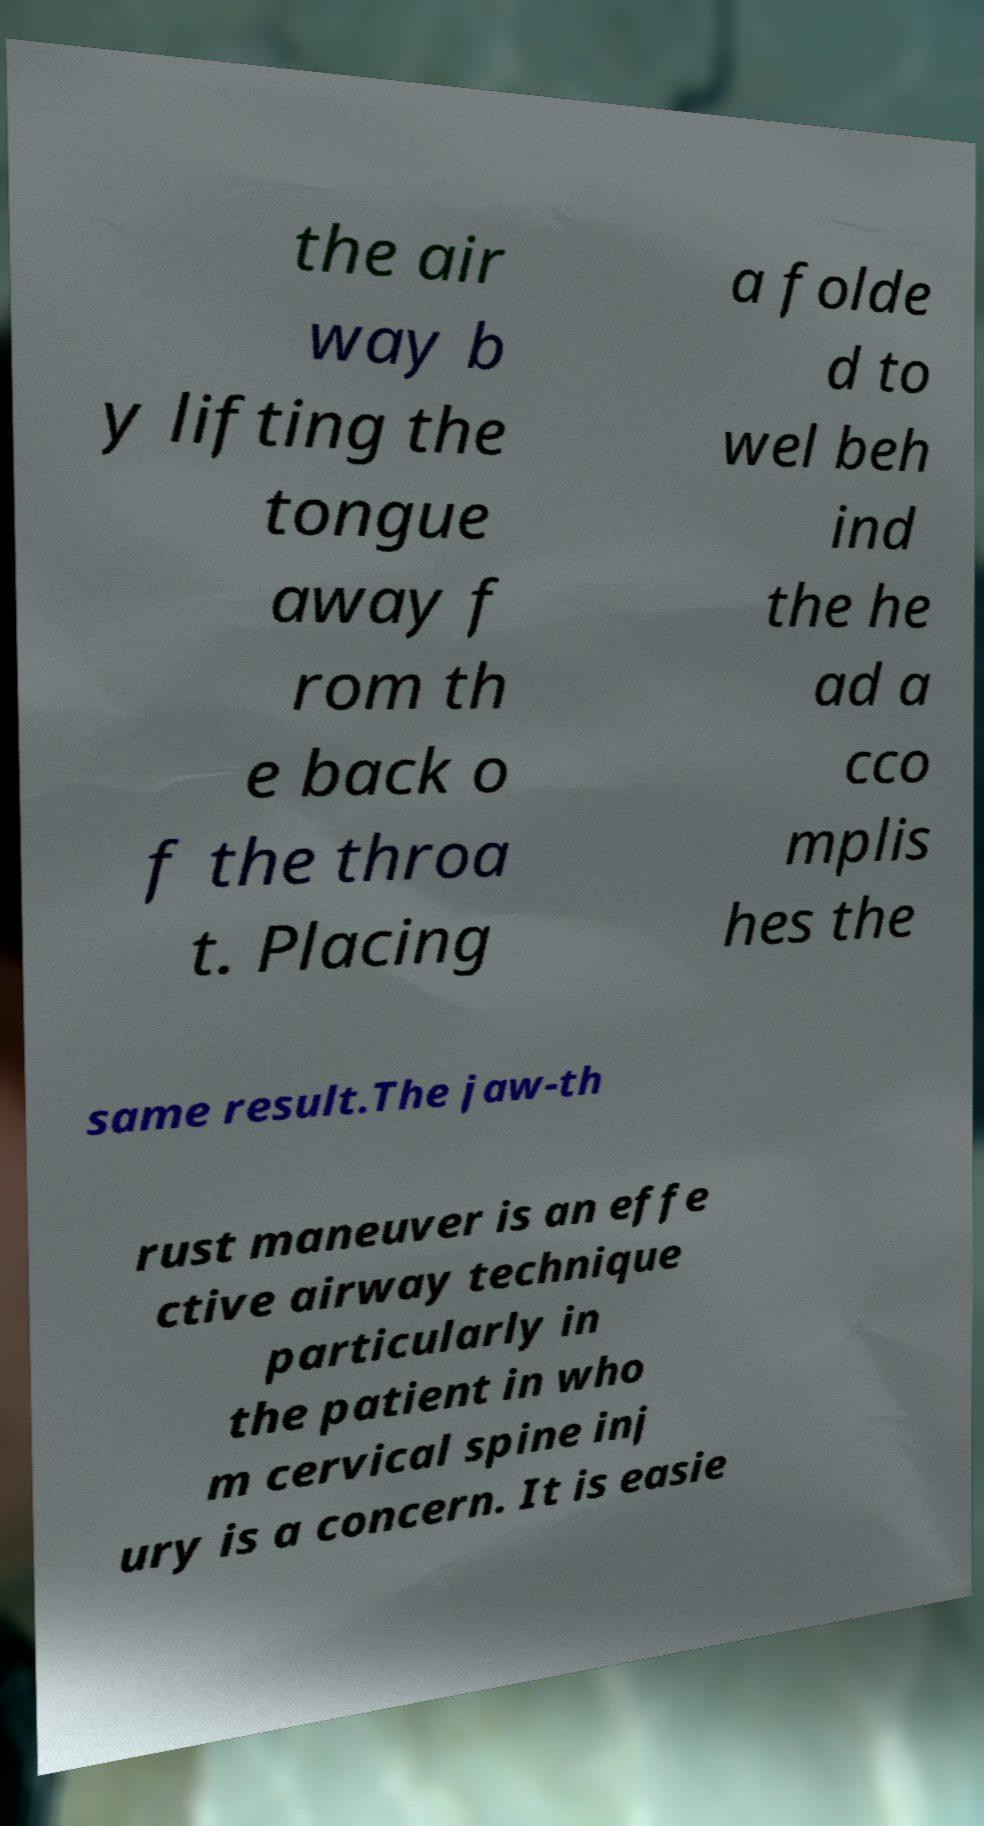For documentation purposes, I need the text within this image transcribed. Could you provide that? the air way b y lifting the tongue away f rom th e back o f the throa t. Placing a folde d to wel beh ind the he ad a cco mplis hes the same result.The jaw-th rust maneuver is an effe ctive airway technique particularly in the patient in who m cervical spine inj ury is a concern. It is easie 